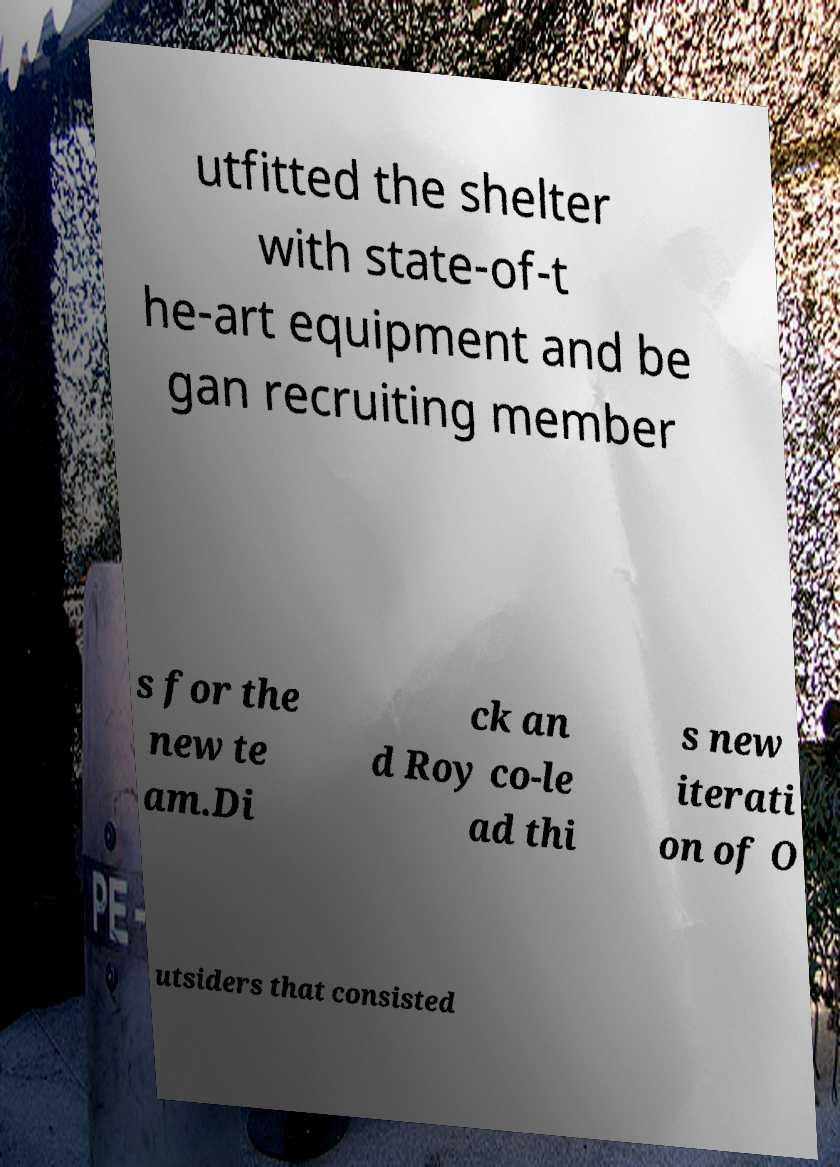I need the written content from this picture converted into text. Can you do that? utfitted the shelter with state-of-t he-art equipment and be gan recruiting member s for the new te am.Di ck an d Roy co-le ad thi s new iterati on of O utsiders that consisted 